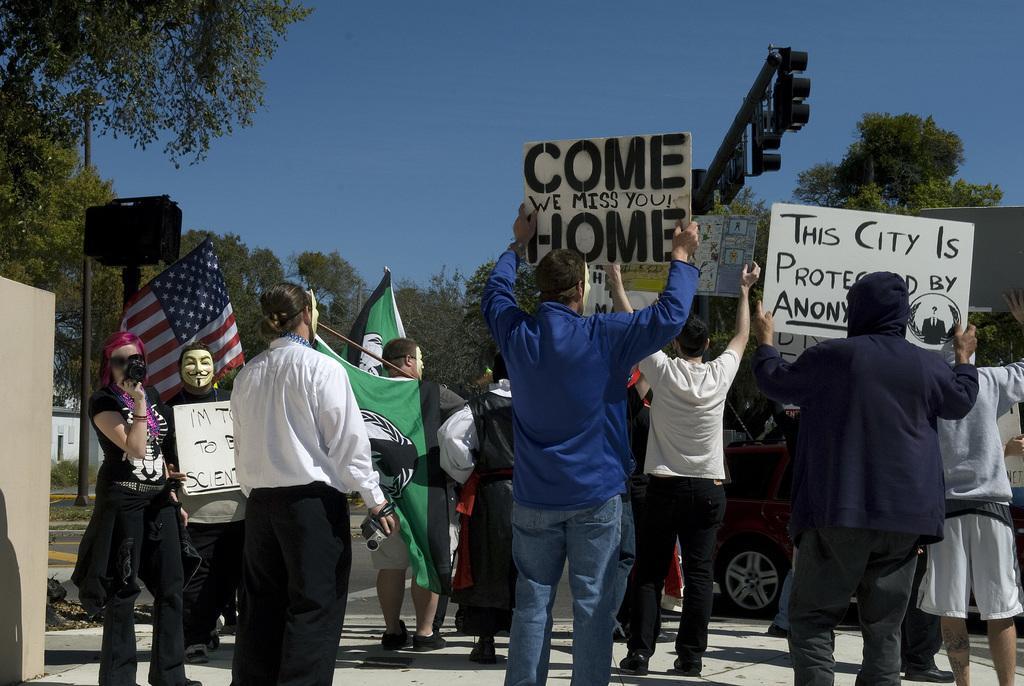Could you give a brief overview of what you see in this image? In this image there are a few people standing and they are wearing masks on their face, few are holding boards with some text, banner and flags. In the background there are trees, poles, signals and the sky. 